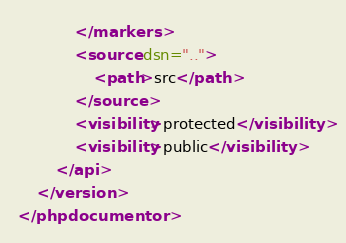Convert code to text. <code><loc_0><loc_0><loc_500><loc_500><_XML_>			</markers>
			<source dsn="..">
				<path>src</path>
			</source>
			<visibility>protected</visibility>
			<visibility>public</visibility>
		</api>
	</version>
</phpdocumentor>
</code> 